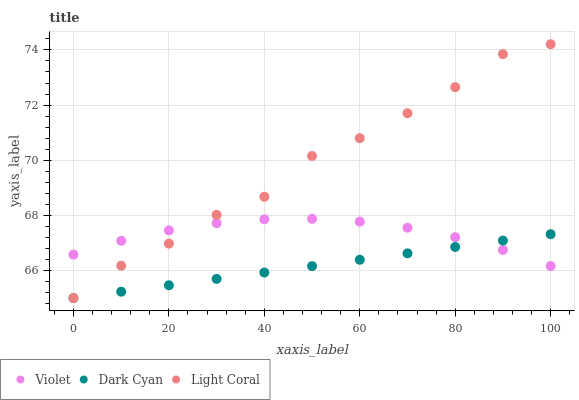Does Dark Cyan have the minimum area under the curve?
Answer yes or no. Yes. Does Light Coral have the maximum area under the curve?
Answer yes or no. Yes. Does Violet have the minimum area under the curve?
Answer yes or no. No. Does Violet have the maximum area under the curve?
Answer yes or no. No. Is Dark Cyan the smoothest?
Answer yes or no. Yes. Is Light Coral the roughest?
Answer yes or no. Yes. Is Violet the smoothest?
Answer yes or no. No. Is Violet the roughest?
Answer yes or no. No. Does Dark Cyan have the lowest value?
Answer yes or no. Yes. Does Violet have the lowest value?
Answer yes or no. No. Does Light Coral have the highest value?
Answer yes or no. Yes. Does Violet have the highest value?
Answer yes or no. No. Does Light Coral intersect Dark Cyan?
Answer yes or no. Yes. Is Light Coral less than Dark Cyan?
Answer yes or no. No. Is Light Coral greater than Dark Cyan?
Answer yes or no. No. 